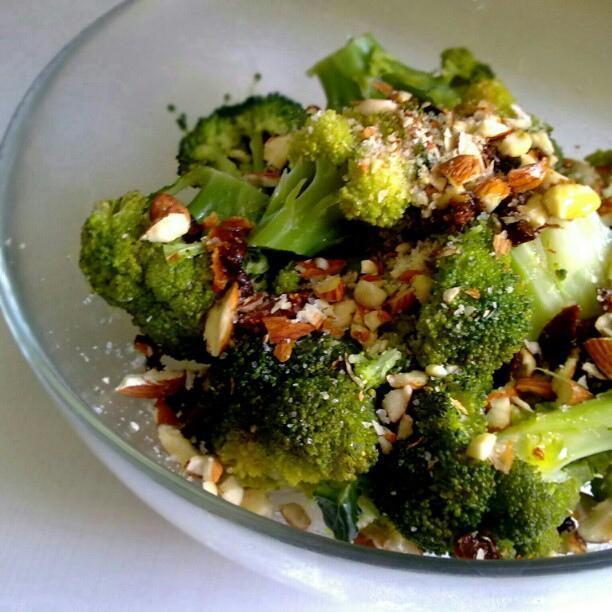How many broccolis are visible?
Give a very brief answer. 7. How many people are holding a green frisbee?
Give a very brief answer. 0. 